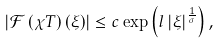<formula> <loc_0><loc_0><loc_500><loc_500>\left | \mathcal { F } \left ( \chi T \right ) \left ( \xi \right ) \right | \leq c \exp \left ( l \left | \xi \right | ^ { \frac { 1 } { \sigma } } \right ) ,</formula> 